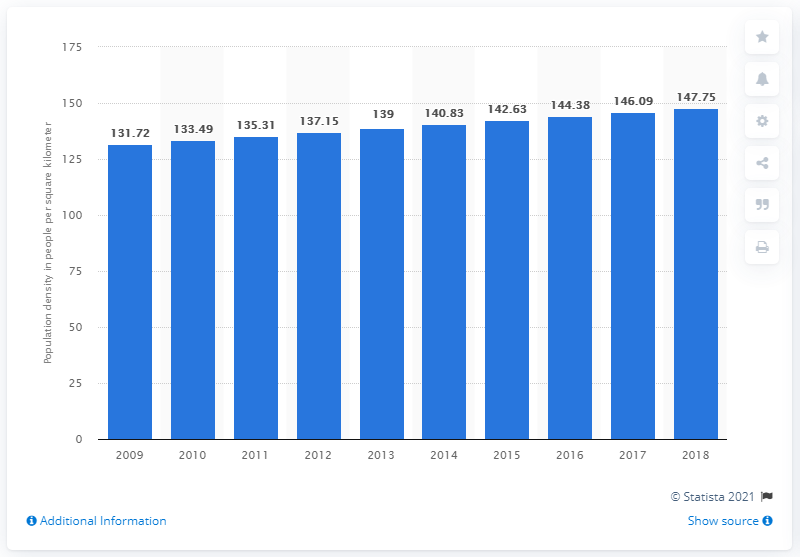Indicate a few pertinent items in this graphic. In 2018, the population density in Indonesia was 147.75 people per square kilometer. 